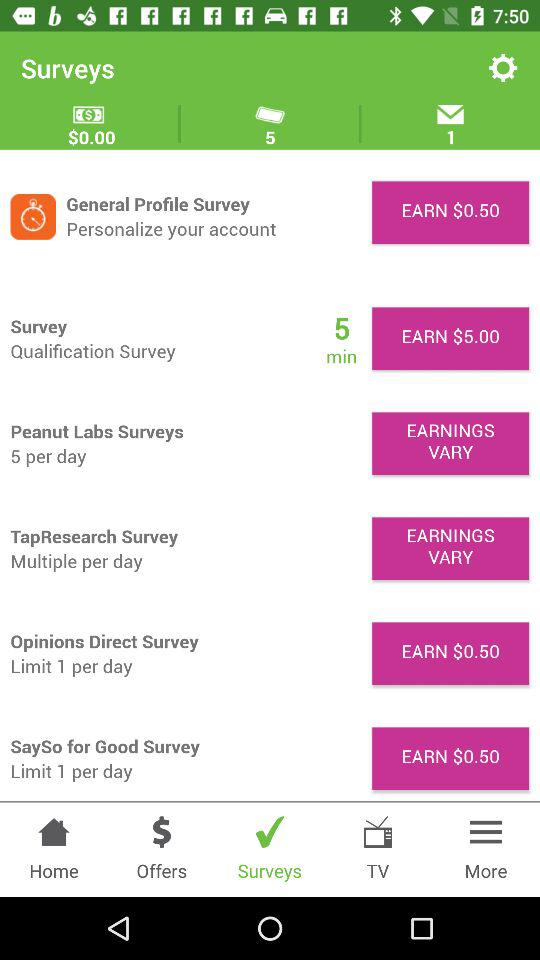What is the per-day limit for the "Opinions Direct Survey"? The limit for "Opinions Direct Survey" is 1 per day. 